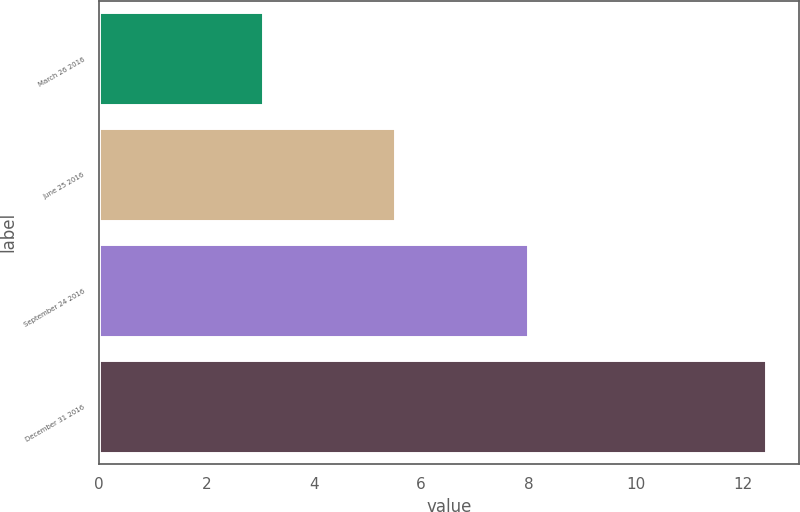Convert chart to OTSL. <chart><loc_0><loc_0><loc_500><loc_500><bar_chart><fcel>March 26 2016<fcel>June 25 2016<fcel>September 24 2016<fcel>December 31 2016<nl><fcel>3.06<fcel>5.52<fcel>8<fcel>12.42<nl></chart> 